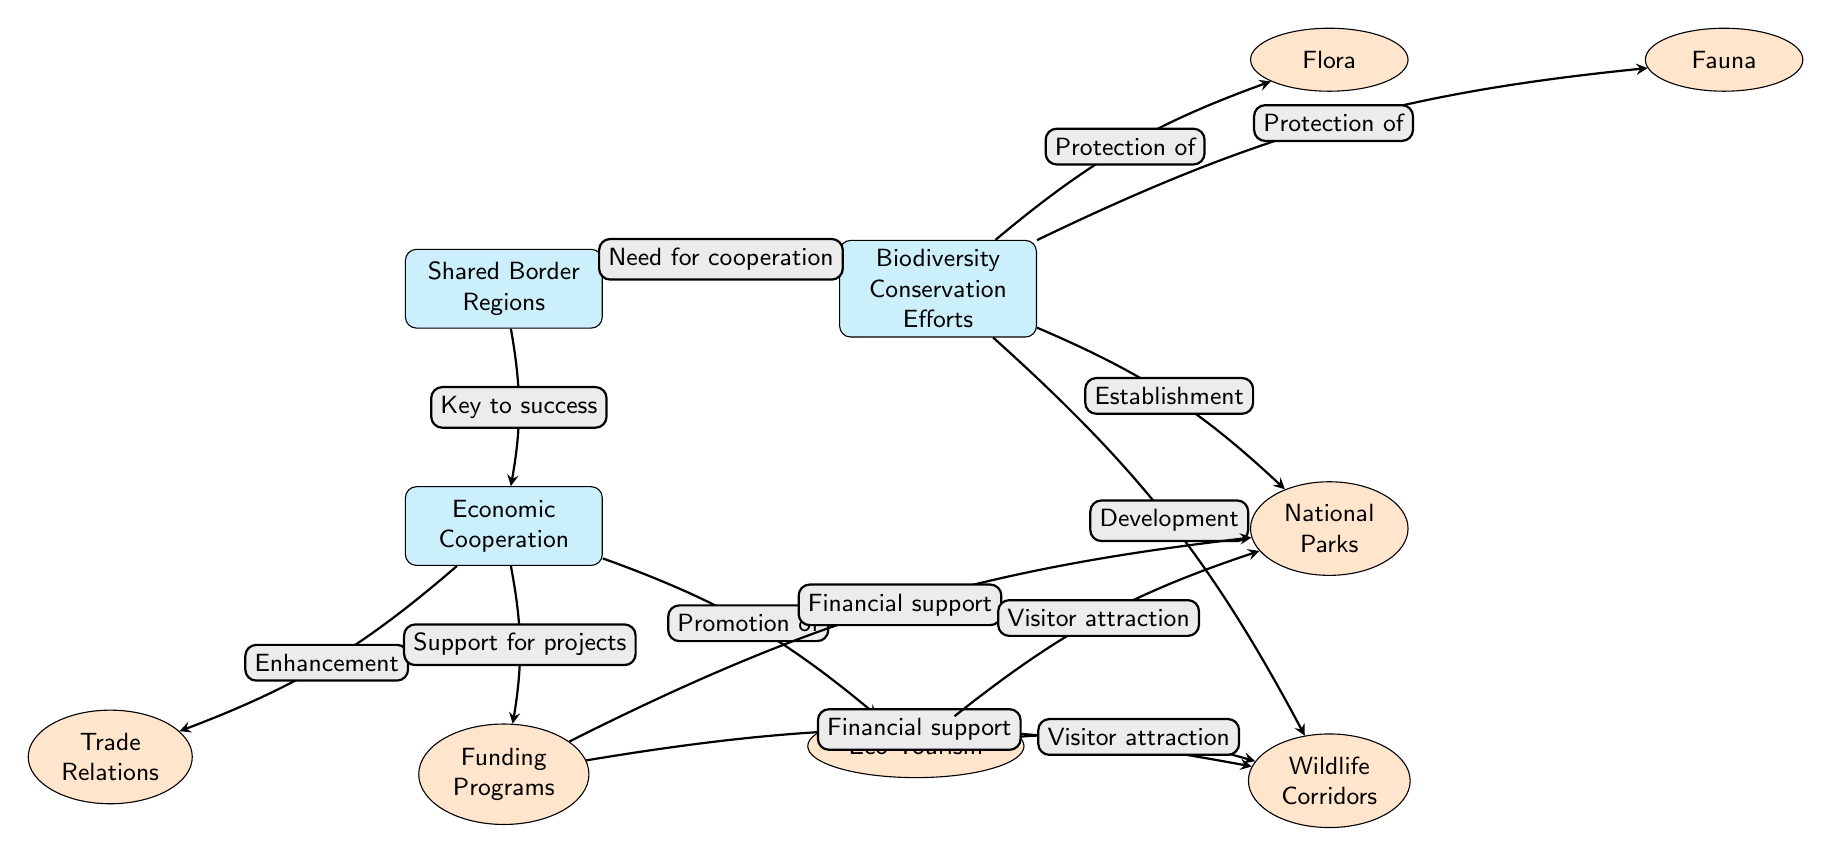What are the two main categories of efforts displayed in this diagram? The main node "Biodiversity Conservation Efforts" splits into two subcategories: "Flora" and "Fauna." These represent the two main categories of conservation efforts depicted in the diagram.
Answer: Flora, Fauna How many sub nodes are there under the "Biodiversity Conservation Efforts" node? Under the "Biodiversity Conservation Efforts" node, there are four sub nodes: "Flora," "Fauna," "National Parks," and "Wildlife Corridors." Counting these, we find there are four sub nodes total.
Answer: 4 What is the relationship between "Economic Cooperation" and "Funding Programs"? The diagram indicates that "Economic Cooperation" supports various projects, with a directed edge pointing from "Economic Cooperation" to "Funding Programs," affirming that economic cooperation provides support in the form of funding.
Answer: Support for projects What does "Eco-Tourism" promote as represented in the diagram? The directed edge from "Eco-Tourism" leads to both "National Parks" and "Wildlife Corridors," showing that eco-tourism promotes visitor attraction for these protected areas.
Answer: Visitor attraction What is the flow of support from "Funding Programs" to "National Parks"? The directed edge indicates that "Funding Programs" provides financial support to "National Parks." This flow signifies that the funding derived from cooperation assists the sustainability of national parks.
Answer: Financial support Why are "Trade Relations," "Funding Programs," and "Eco-Tourism" important in relation to the shared border regions? These three elements are under the node "Economic Cooperation," which emphasizes their roles in enhancing economic ties that are necessary for the success of biodiversity conservation efforts, as explained by the edges connecting them in the diagram.
Answer: Key to success How does the diagram connect "Shared Border Regions" to "Biodiversity Conservation Efforts"? The directed edge from "Shared Border Regions" to "Biodiversity Conservation Efforts" indicates a clear relationship, implying that the need for cooperation in these regions is essential for achieving successful biodiversity conservation.
Answer: Need for cooperation What is established as a result of the biodiversity conservation efforts? The directed edge from "Biodiversity Conservation Efforts" toward "National Parks" denotes that the establishment of national parks is a direct outcome of the conservation efforts depicted in the diagram.
Answer: Establishment How many direct connections lead out of the "Economic Cooperation" node? The "Economic Cooperation" node has three direct connections leading to "Trade Relations," "Funding Programs," and "Eco-Tourism." Counting these connections confirms that there are three distinct pathways outlined.
Answer: 3 